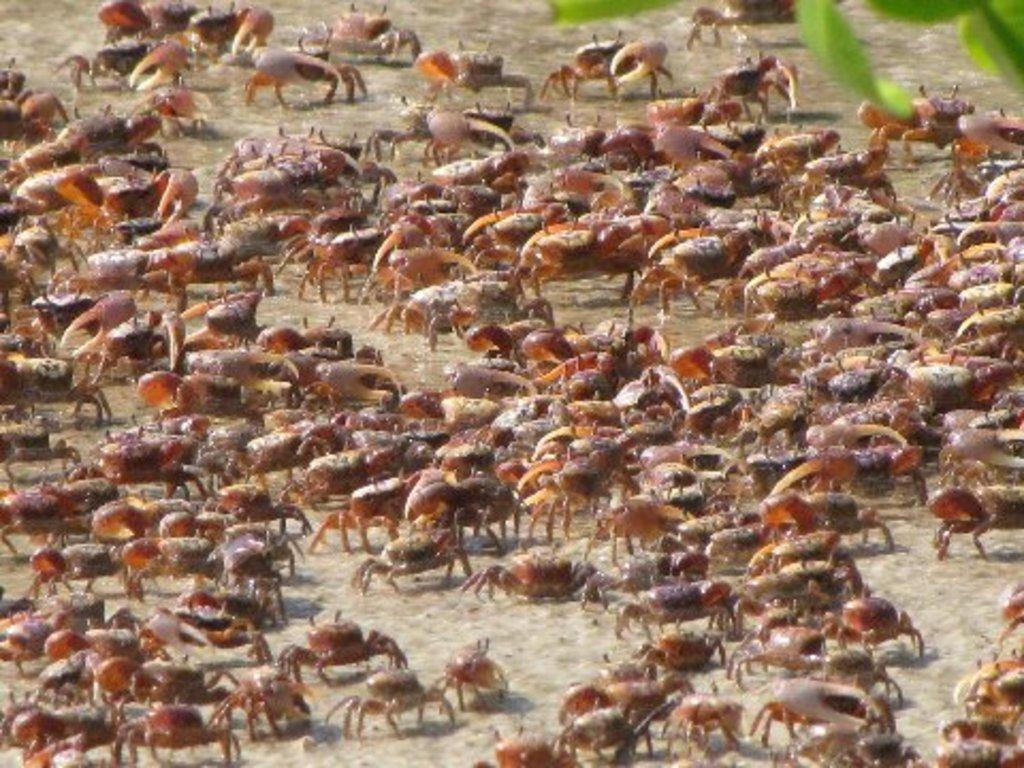Please provide a concise description of this image. In this image we can see a group of insects on sand, at the top we can see some leaves truncated. 